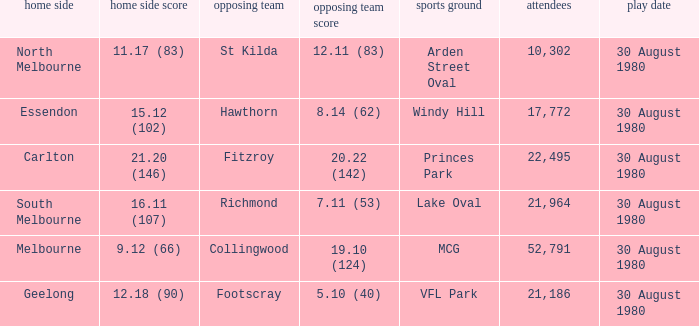What was the crowd when the away team is footscray? 21186.0. 